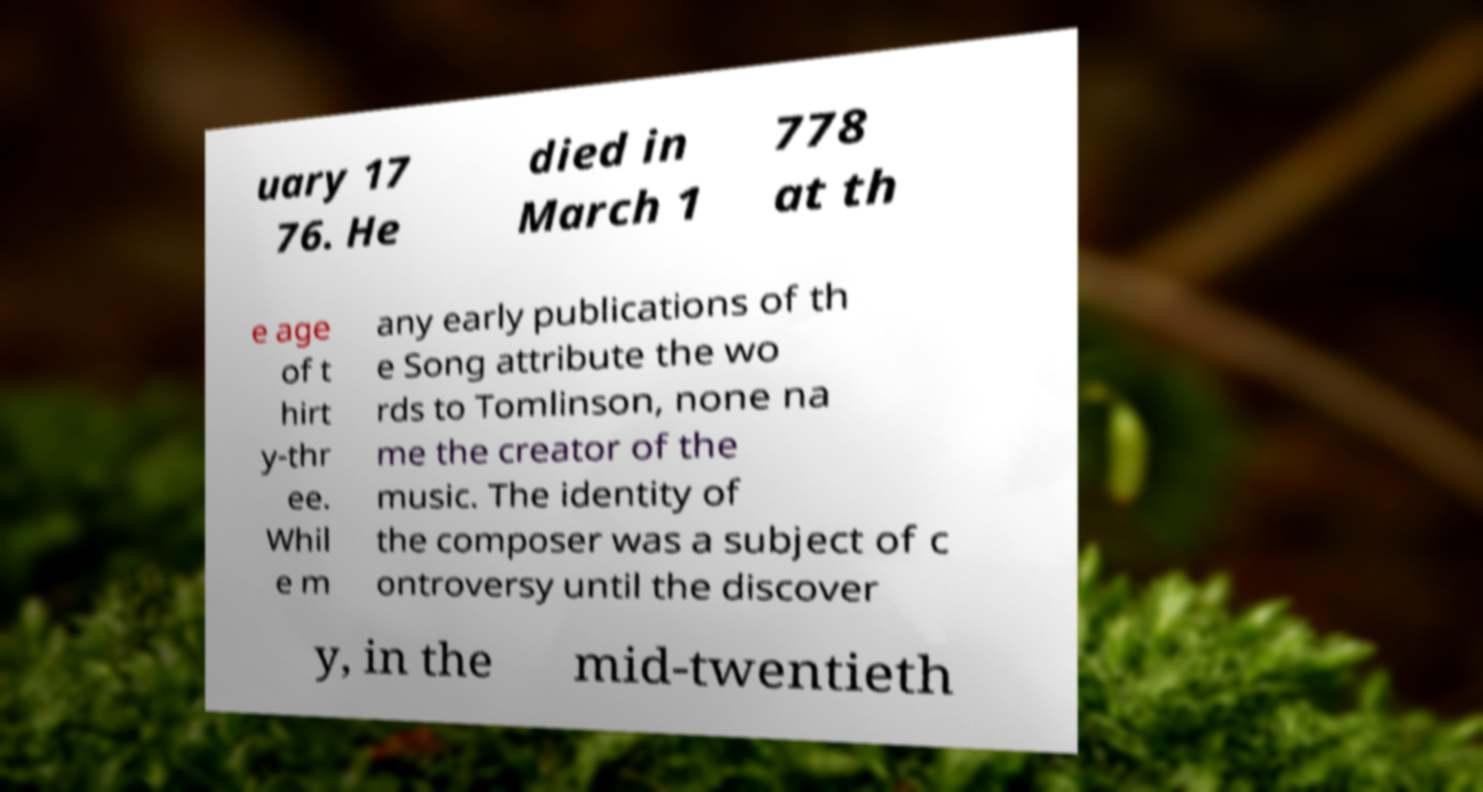For documentation purposes, I need the text within this image transcribed. Could you provide that? uary 17 76. He died in March 1 778 at th e age of t hirt y-thr ee. Whil e m any early publications of th e Song attribute the wo rds to Tomlinson, none na me the creator of the music. The identity of the composer was a subject of c ontroversy until the discover y, in the mid-twentieth 